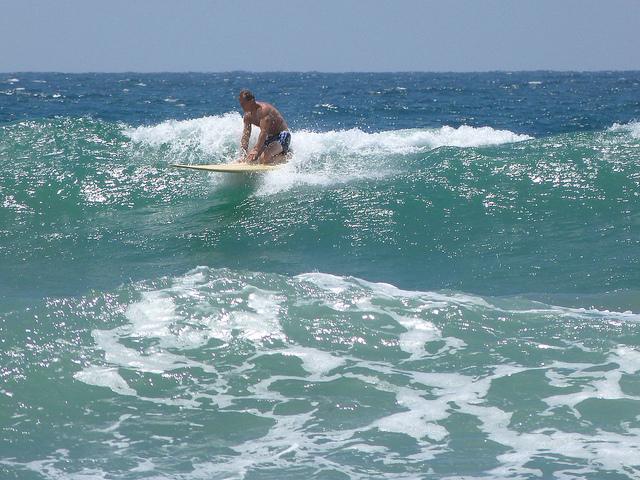Is this man wearing a shirt?
Be succinct. No. What is this man doing?
Short answer required. Surfing. What color is the man's surfboard?
Quick response, please. Yellow. 